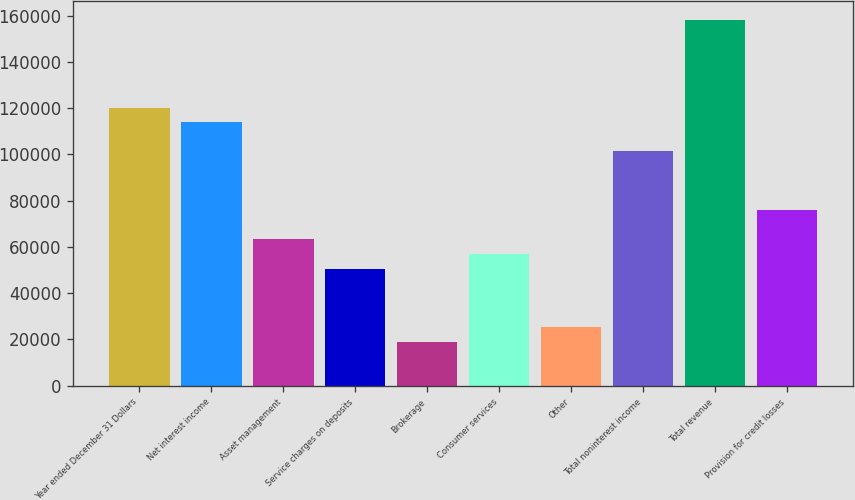<chart> <loc_0><loc_0><loc_500><loc_500><bar_chart><fcel>Year ended December 31 Dollars<fcel>Net interest income<fcel>Asset management<fcel>Service charges on deposits<fcel>Brokerage<fcel>Consumer services<fcel>Other<fcel>Total noninterest income<fcel>Total revenue<fcel>Provision for credit losses<nl><fcel>120298<fcel>113967<fcel>63320<fcel>50658.2<fcel>19003.7<fcel>56989.1<fcel>25334.6<fcel>101305<fcel>158284<fcel>75981.8<nl></chart> 